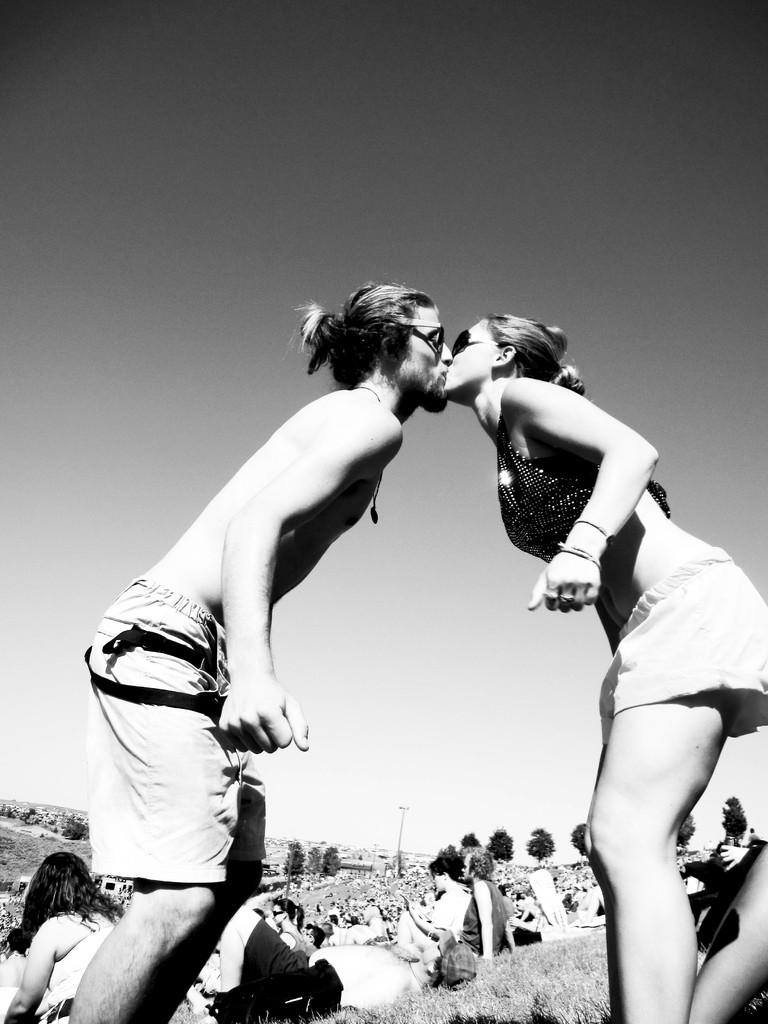Who are the two people in the image? There is a man and a woman in the image. What are the man and woman doing in the image? The man and woman are kissing. What can be seen in the background of the image? There are persons sitting on the ground and trees in the background of the image. What is visible in the sky in the image? The sky is visible in the background of the image. What type of fiction is the man reading to the woman in the image? There is no book or any form of fiction present in the image; the man and woman are kissing. What is the floor made of in the image? The image does not show the floor, so it cannot be determined what material it is made of. 